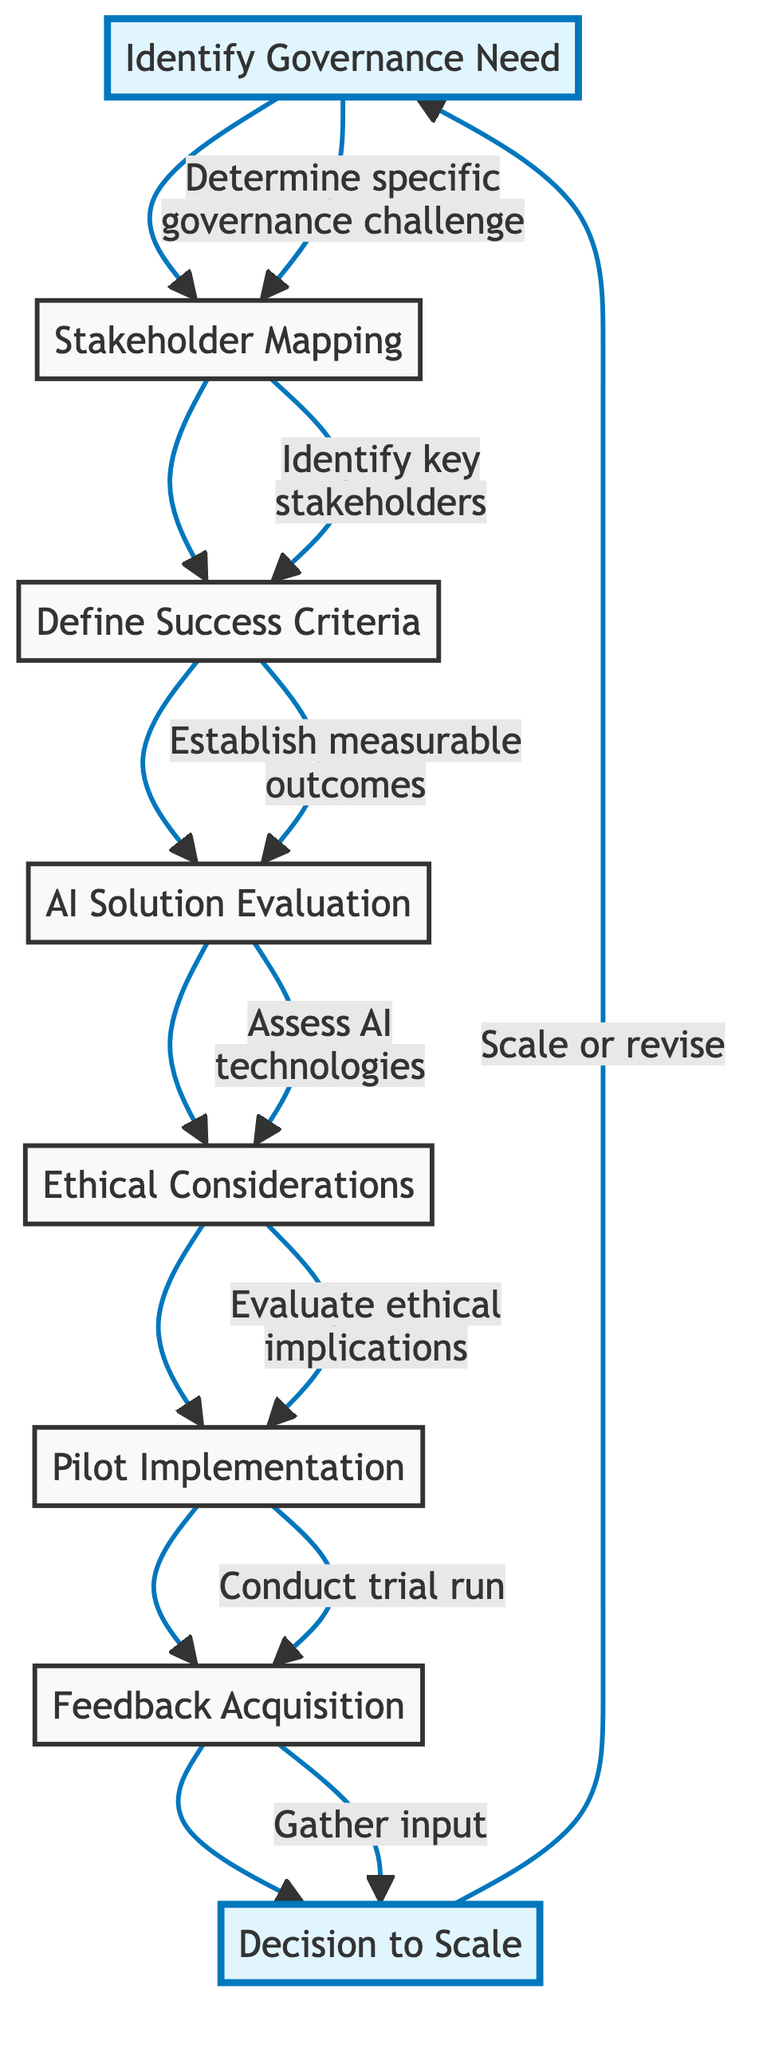What is the first step in the decision-making framework? The first step in the diagram is represented by the node "Identify Governance Need." This is the starting point of the flowchart.
Answer: Identify Governance Need How many nodes are there in the diagram? By counting the elements listed in the flowchart, we see there are a total of eight distinct nodes representing various steps in the decision-making process.
Answer: Eight What step follows "Ethical Considerations"? The flowchart indicates that "Pilot Implementation" follows "Ethical Considerations." This shows the sequential nature of the decision-making framework.
Answer: Pilot Implementation Which step involves gathering input? The node labeled "Feedback Acquisition" involves gathering input from stakeholders and users regarding the pilot implementation, as specified in the description.
Answer: Feedback Acquisition What is the last step before a decision to scale the AI solution? The final step before the "Decision to Scale" is "Feedback Acquisition," where input from stakeholders is collected. This input influences the final decision about scaling.
Answer: Feedback Acquisition What does the "AI Solution Evaluation" step involve? The "AI Solution Evaluation" step involves assessing various AI technologies for their applicability, effectiveness, and feasibility, based on established criteria.
Answer: Assess various AI technologies What happens after "Pilot Implementation"? After the "Pilot Implementation," the next step is "Feedback Acquisition," where stakeholders provide input about the pilot's effectiveness.
Answer: Feedback Acquisition Which step is specifically about ethical implications? The step concerned with ethical implications is labeled "Ethical Considerations," focusing on aspects like bias, privacy, and transparency.
Answer: Ethical Considerations How does "Identify Governance Need" connect to "Stakeholder Mapping"? The connection shows that once a specific governance challenge is identified, the next logical step is to identify the relevant stakeholders involved in the governance process.
Answer: Identify key stakeholders 